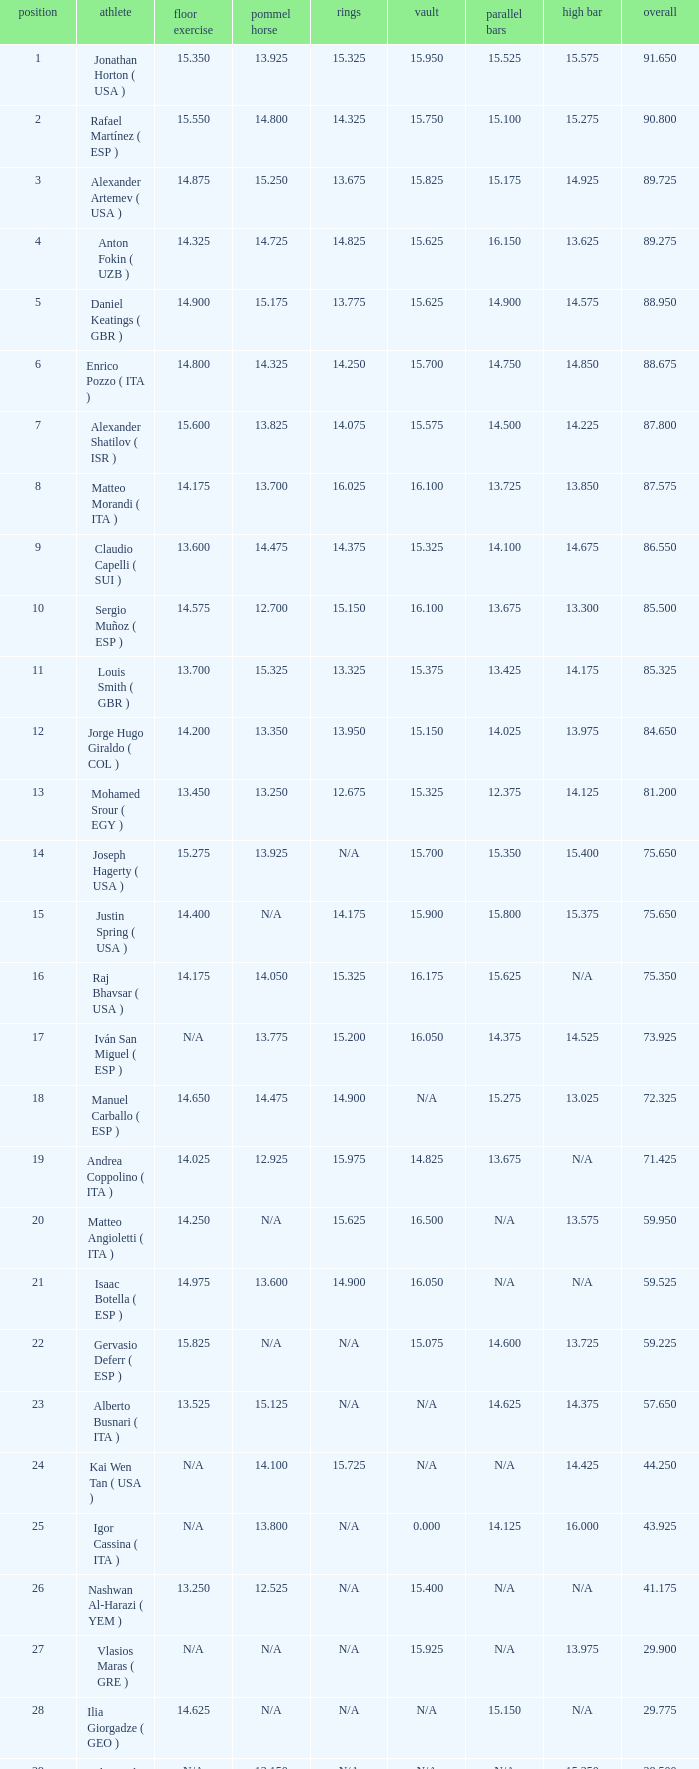Given that the floor's number is 14.200, what is the parallel bars' number? 14.025. 